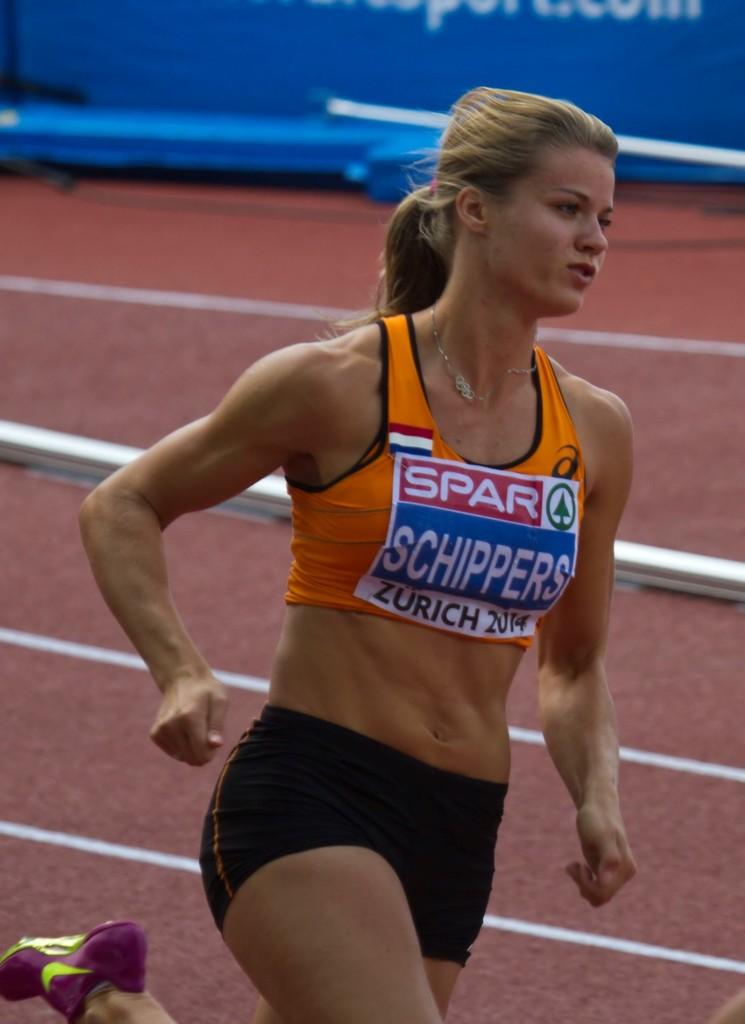What country is the athlete from?
Offer a terse response. Zurich. What track meet is this?
Offer a terse response. Schippers. 